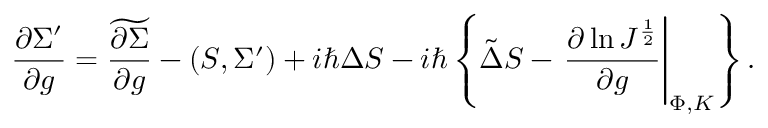Convert formula to latex. <formula><loc_0><loc_0><loc_500><loc_500>{ \frac { \partial \Sigma ^ { \prime } } { \partial g } } = \widetilde { \frac { \partial \Sigma } { \partial g } } - ( S , \Sigma ^ { \prime } ) + i \hbar { \Delta } S - i \hbar { \left } \{ \tilde { \Delta } S - { \frac { \partial \ln J ^ { \frac { 1 } { 2 } } } { \partial g } } \right | _ { \Phi , K } \right \} .</formula> 